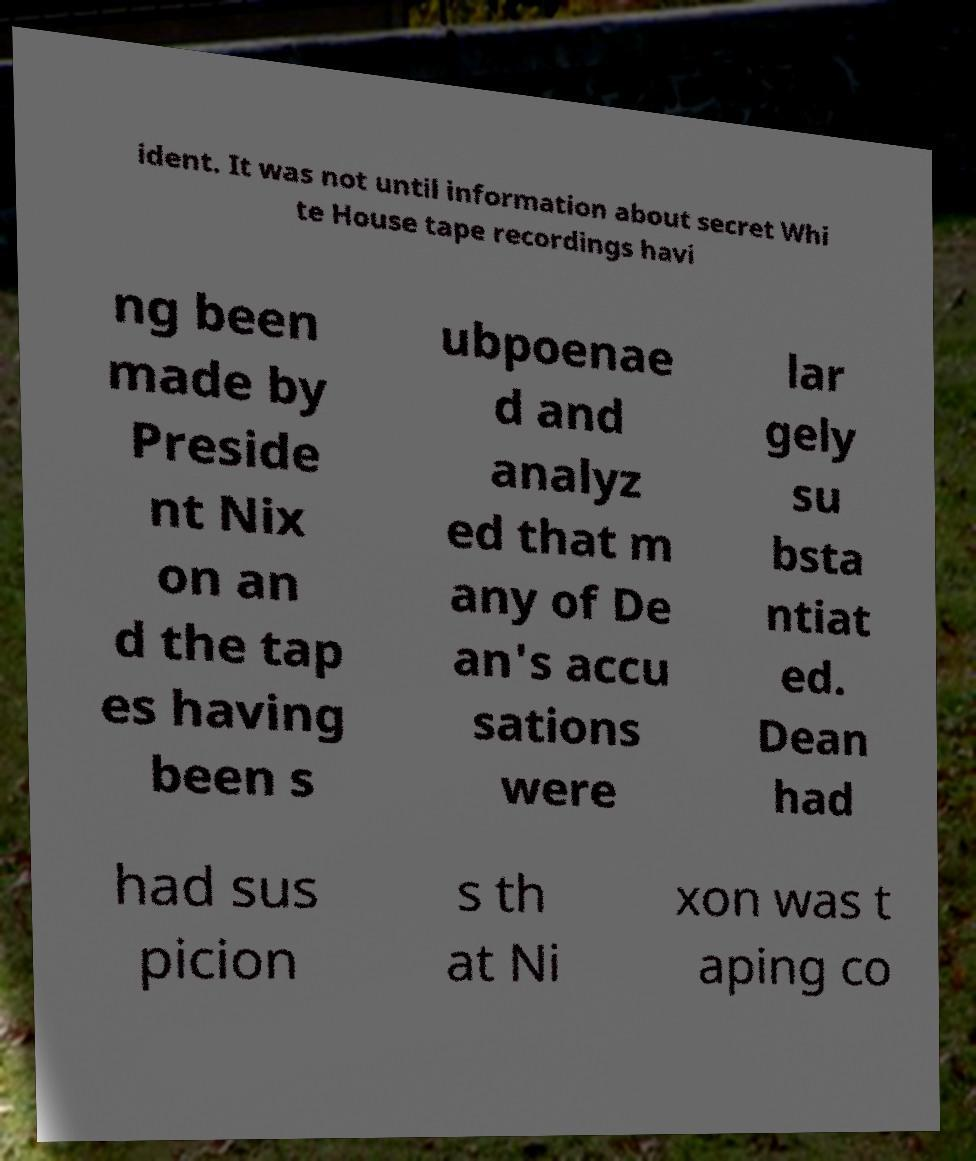Can you accurately transcribe the text from the provided image for me? ident. It was not until information about secret Whi te House tape recordings havi ng been made by Preside nt Nix on an d the tap es having been s ubpoenae d and analyz ed that m any of De an's accu sations were lar gely su bsta ntiat ed. Dean had had sus picion s th at Ni xon was t aping co 